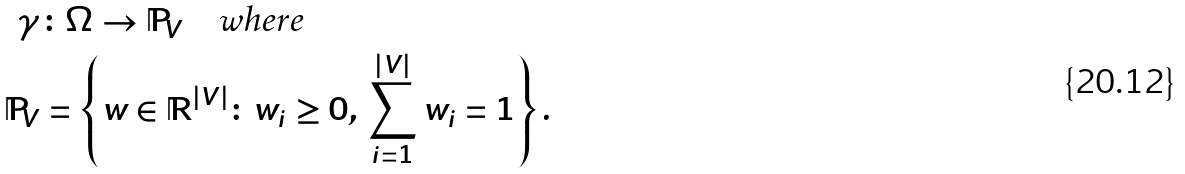Convert formula to latex. <formula><loc_0><loc_0><loc_500><loc_500>\gamma & \colon \Omega \to \mathbb { P } _ { V } \quad \text {where} \\ \mathbb { P } _ { V } & = \left \{ w \in \mathbb { R } ^ { | V | } \colon w _ { i } \geq 0 , \, \sum _ { i = 1 } ^ { | V | } w _ { i } = 1 \right \} .</formula> 